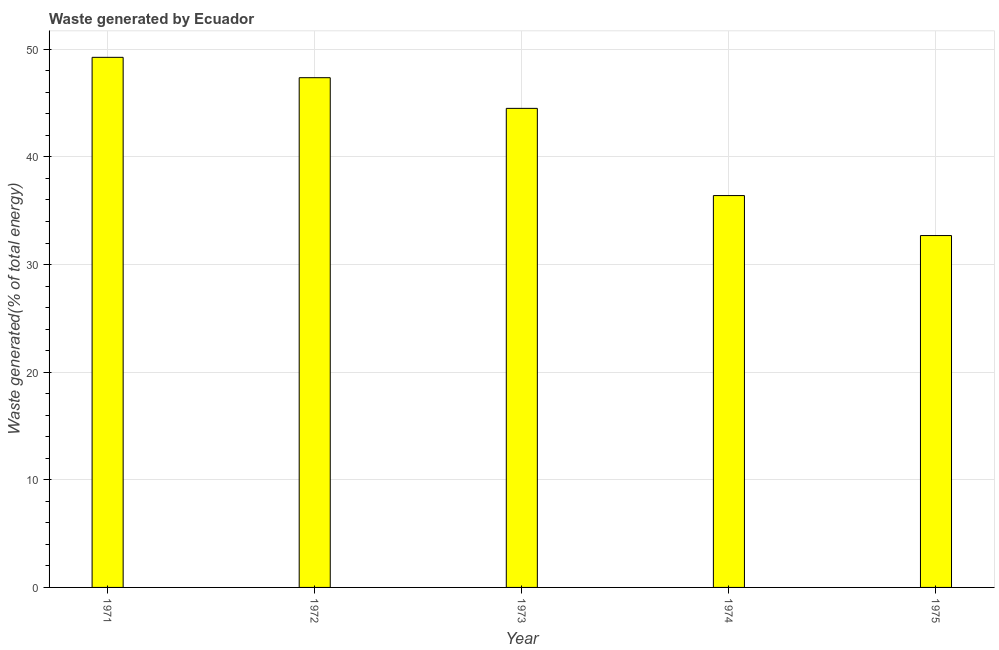Does the graph contain any zero values?
Provide a short and direct response. No. What is the title of the graph?
Make the answer very short. Waste generated by Ecuador. What is the label or title of the X-axis?
Your answer should be very brief. Year. What is the label or title of the Y-axis?
Provide a succinct answer. Waste generated(% of total energy). What is the amount of waste generated in 1972?
Your answer should be very brief. 47.36. Across all years, what is the maximum amount of waste generated?
Ensure brevity in your answer.  49.25. Across all years, what is the minimum amount of waste generated?
Your response must be concise. 32.69. In which year was the amount of waste generated maximum?
Your response must be concise. 1971. In which year was the amount of waste generated minimum?
Provide a short and direct response. 1975. What is the sum of the amount of waste generated?
Your answer should be compact. 210.22. What is the difference between the amount of waste generated in 1974 and 1975?
Provide a succinct answer. 3.71. What is the average amount of waste generated per year?
Your answer should be compact. 42.04. What is the median amount of waste generated?
Make the answer very short. 44.51. Do a majority of the years between 1975 and 1974 (inclusive) have amount of waste generated greater than 8 %?
Provide a short and direct response. No. What is the ratio of the amount of waste generated in 1974 to that in 1975?
Ensure brevity in your answer.  1.11. What is the difference between the highest and the second highest amount of waste generated?
Offer a terse response. 1.89. Is the sum of the amount of waste generated in 1972 and 1975 greater than the maximum amount of waste generated across all years?
Offer a terse response. Yes. What is the difference between the highest and the lowest amount of waste generated?
Keep it short and to the point. 16.56. In how many years, is the amount of waste generated greater than the average amount of waste generated taken over all years?
Your answer should be compact. 3. What is the difference between two consecutive major ticks on the Y-axis?
Offer a very short reply. 10. What is the Waste generated(% of total energy) in 1971?
Offer a terse response. 49.25. What is the Waste generated(% of total energy) in 1972?
Provide a short and direct response. 47.36. What is the Waste generated(% of total energy) of 1973?
Your response must be concise. 44.51. What is the Waste generated(% of total energy) of 1974?
Your answer should be very brief. 36.41. What is the Waste generated(% of total energy) in 1975?
Your response must be concise. 32.69. What is the difference between the Waste generated(% of total energy) in 1971 and 1972?
Your response must be concise. 1.89. What is the difference between the Waste generated(% of total energy) in 1971 and 1973?
Provide a short and direct response. 4.74. What is the difference between the Waste generated(% of total energy) in 1971 and 1974?
Offer a terse response. 12.84. What is the difference between the Waste generated(% of total energy) in 1971 and 1975?
Keep it short and to the point. 16.56. What is the difference between the Waste generated(% of total energy) in 1972 and 1973?
Offer a very short reply. 2.85. What is the difference between the Waste generated(% of total energy) in 1972 and 1974?
Your answer should be compact. 10.95. What is the difference between the Waste generated(% of total energy) in 1972 and 1975?
Keep it short and to the point. 14.67. What is the difference between the Waste generated(% of total energy) in 1973 and 1974?
Provide a succinct answer. 8.1. What is the difference between the Waste generated(% of total energy) in 1973 and 1975?
Provide a short and direct response. 11.82. What is the difference between the Waste generated(% of total energy) in 1974 and 1975?
Ensure brevity in your answer.  3.71. What is the ratio of the Waste generated(% of total energy) in 1971 to that in 1973?
Give a very brief answer. 1.11. What is the ratio of the Waste generated(% of total energy) in 1971 to that in 1974?
Make the answer very short. 1.35. What is the ratio of the Waste generated(% of total energy) in 1971 to that in 1975?
Make the answer very short. 1.51. What is the ratio of the Waste generated(% of total energy) in 1972 to that in 1973?
Ensure brevity in your answer.  1.06. What is the ratio of the Waste generated(% of total energy) in 1972 to that in 1974?
Your answer should be very brief. 1.3. What is the ratio of the Waste generated(% of total energy) in 1972 to that in 1975?
Provide a succinct answer. 1.45. What is the ratio of the Waste generated(% of total energy) in 1973 to that in 1974?
Your answer should be compact. 1.22. What is the ratio of the Waste generated(% of total energy) in 1973 to that in 1975?
Offer a terse response. 1.36. What is the ratio of the Waste generated(% of total energy) in 1974 to that in 1975?
Ensure brevity in your answer.  1.11. 